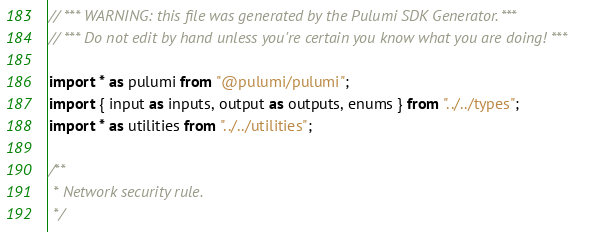Convert code to text. <code><loc_0><loc_0><loc_500><loc_500><_TypeScript_>// *** WARNING: this file was generated by the Pulumi SDK Generator. ***
// *** Do not edit by hand unless you're certain you know what you are doing! ***

import * as pulumi from "@pulumi/pulumi";
import { input as inputs, output as outputs, enums } from "../../types";
import * as utilities from "../../utilities";

/**
 * Network security rule.
 */</code> 